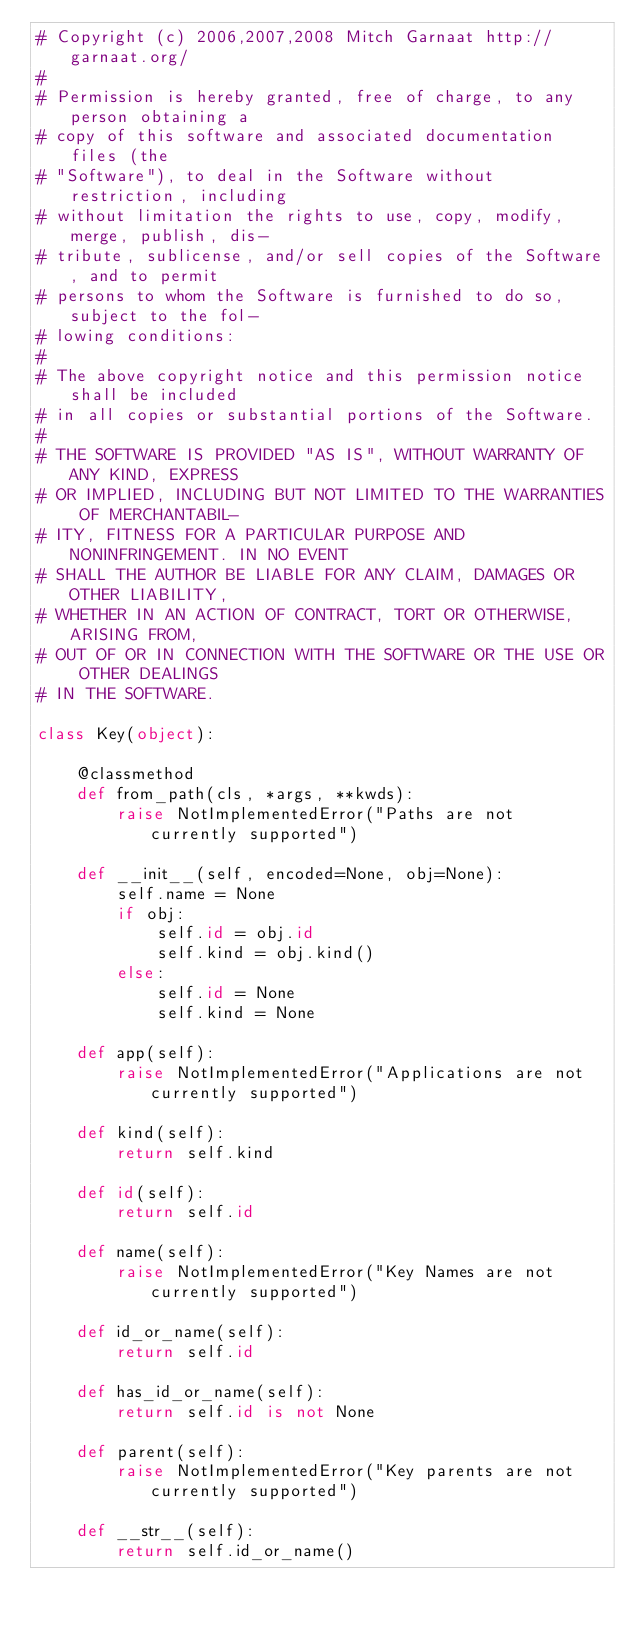<code> <loc_0><loc_0><loc_500><loc_500><_Python_># Copyright (c) 2006,2007,2008 Mitch Garnaat http://garnaat.org/
#
# Permission is hereby granted, free of charge, to any person obtaining a
# copy of this software and associated documentation files (the
# "Software"), to deal in the Software without restriction, including
# without limitation the rights to use, copy, modify, merge, publish, dis-
# tribute, sublicense, and/or sell copies of the Software, and to permit
# persons to whom the Software is furnished to do so, subject to the fol-
# lowing conditions:
#
# The above copyright notice and this permission notice shall be included
# in all copies or substantial portions of the Software.
#
# THE SOFTWARE IS PROVIDED "AS IS", WITHOUT WARRANTY OF ANY KIND, EXPRESS
# OR IMPLIED, INCLUDING BUT NOT LIMITED TO THE WARRANTIES OF MERCHANTABIL-
# ITY, FITNESS FOR A PARTICULAR PURPOSE AND NONINFRINGEMENT. IN NO EVENT
# SHALL THE AUTHOR BE LIABLE FOR ANY CLAIM, DAMAGES OR OTHER LIABILITY,
# WHETHER IN AN ACTION OF CONTRACT, TORT OR OTHERWISE, ARISING FROM,
# OUT OF OR IN CONNECTION WITH THE SOFTWARE OR THE USE OR OTHER DEALINGS
# IN THE SOFTWARE.

class Key(object):

    @classmethod
    def from_path(cls, *args, **kwds):
        raise NotImplementedError("Paths are not currently supported")

    def __init__(self, encoded=None, obj=None):
        self.name = None
        if obj:
            self.id = obj.id
            self.kind = obj.kind()
        else:
            self.id = None
            self.kind = None

    def app(self):
        raise NotImplementedError("Applications are not currently supported")

    def kind(self):
        return self.kind

    def id(self):
        return self.id

    def name(self):
        raise NotImplementedError("Key Names are not currently supported")

    def id_or_name(self):
        return self.id

    def has_id_or_name(self):
        return self.id is not None

    def parent(self):
        raise NotImplementedError("Key parents are not currently supported")

    def __str__(self):
        return self.id_or_name()
</code> 